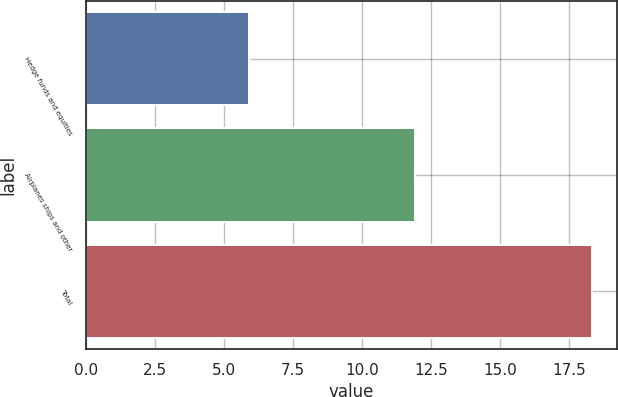<chart> <loc_0><loc_0><loc_500><loc_500><bar_chart><fcel>Hedge funds and equities<fcel>Airplanes ships and other<fcel>Total<nl><fcel>5.9<fcel>11.9<fcel>18.3<nl></chart> 